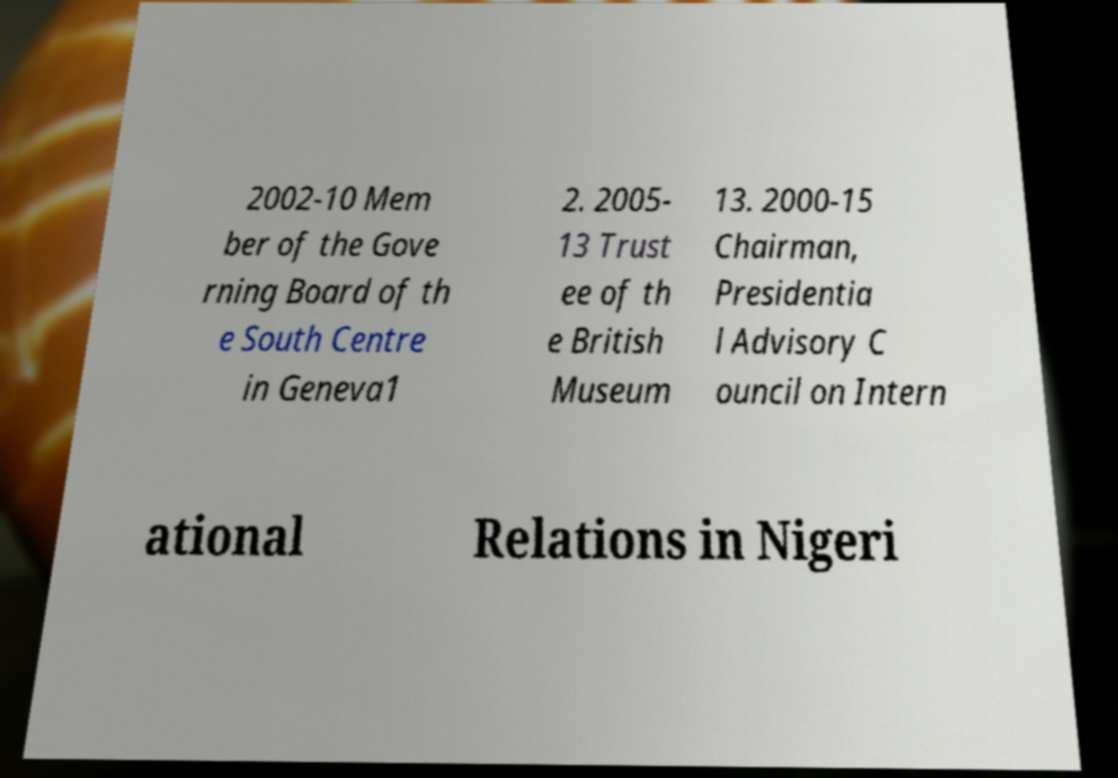What messages or text are displayed in this image? I need them in a readable, typed format. 2002-10 Mem ber of the Gove rning Board of th e South Centre in Geneva1 2. 2005- 13 Trust ee of th e British Museum 13. 2000-15 Chairman, Presidentia l Advisory C ouncil on Intern ational Relations in Nigeri 